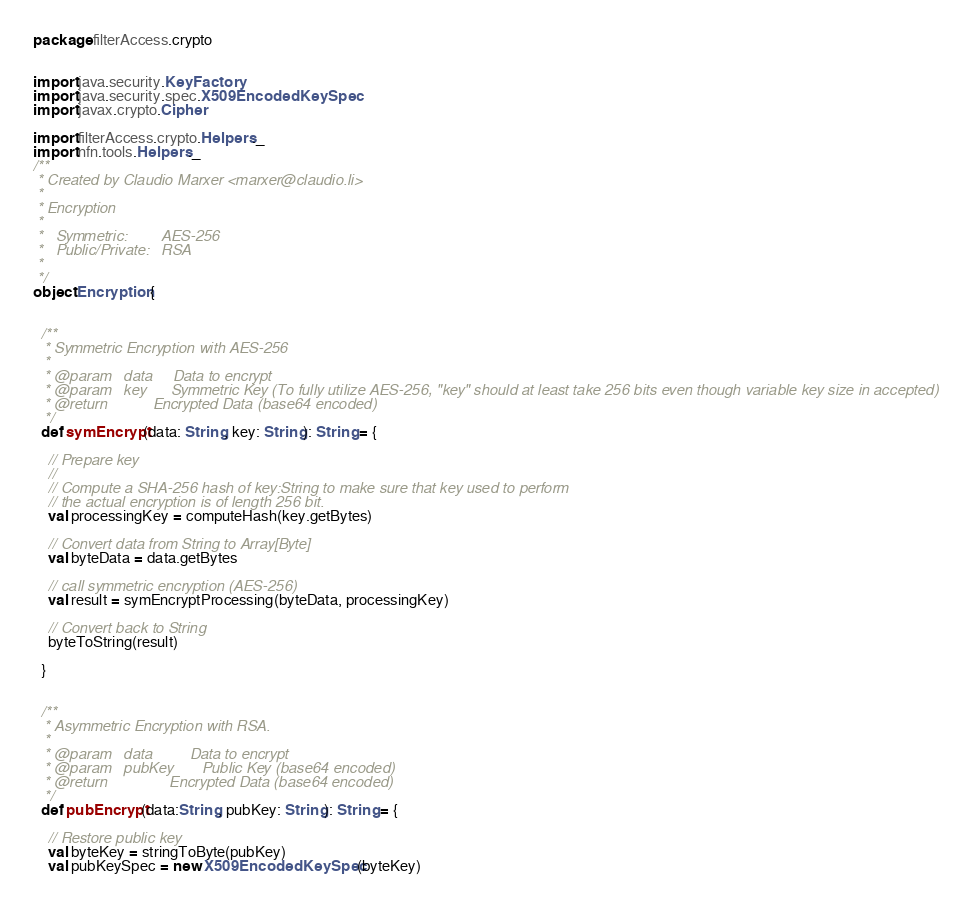<code> <loc_0><loc_0><loc_500><loc_500><_Scala_>package filterAccess.crypto


import java.security.KeyFactory
import java.security.spec.X509EncodedKeySpec
import javax.crypto.Cipher

import filterAccess.crypto.Helpers._
import nfn.tools.Helpers._
/**
 * Created by Claudio Marxer <marxer@claudio.li>
 *
 * Encryption
 *
 *   Symmetric:        AES-256
 *   Public/Private:   RSA
 *
 */
object Encryption {


  /**
   * Symmetric Encryption with AES-256
   *
   * @param   data     Data to encrypt
   * @param   key      Symmetric Key (To fully utilize AES-256, "key" should at least take 256 bits even though variable key size in accepted)
   * @return           Encrypted Data (base64 encoded)
   */
  def symEncrypt(data: String, key: String): String = {

    // Prepare key
    //
    // Compute a SHA-256 hash of key:String to make sure that key used to perform
    // the actual encryption is of length 256 bit.
    val processingKey = computeHash(key.getBytes)

    // Convert data from String to Array[Byte]
    val byteData = data.getBytes

    // call symmetric encryption (AES-256)
    val result = symEncryptProcessing(byteData, processingKey)

    // Convert back to String
    byteToString(result)

  }


  /**
   * Asymmetric Encryption with RSA.
   *
   * @param   data         Data to encrypt
   * @param   pubKey       Public Key (base64 encoded)
   * @return               Encrypted Data (base64 encoded)
   */
  def pubEncrypt(data:String, pubKey: String): String = {

    // Restore public key
    val byteKey = stringToByte(pubKey)
    val pubKeySpec = new X509EncodedKeySpec(byteKey)</code> 